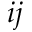<formula> <loc_0><loc_0><loc_500><loc_500>i j</formula> 